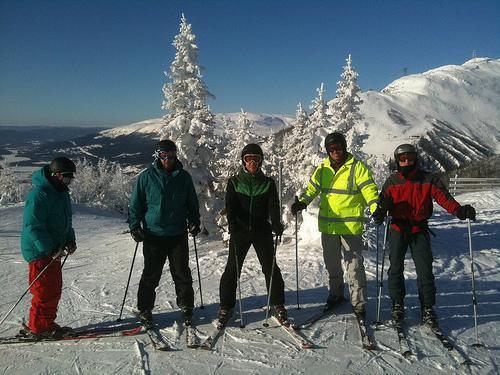How many skiers?
Give a very brief answer. 5. How many people are wearing gloves?
Give a very brief answer. 5. 